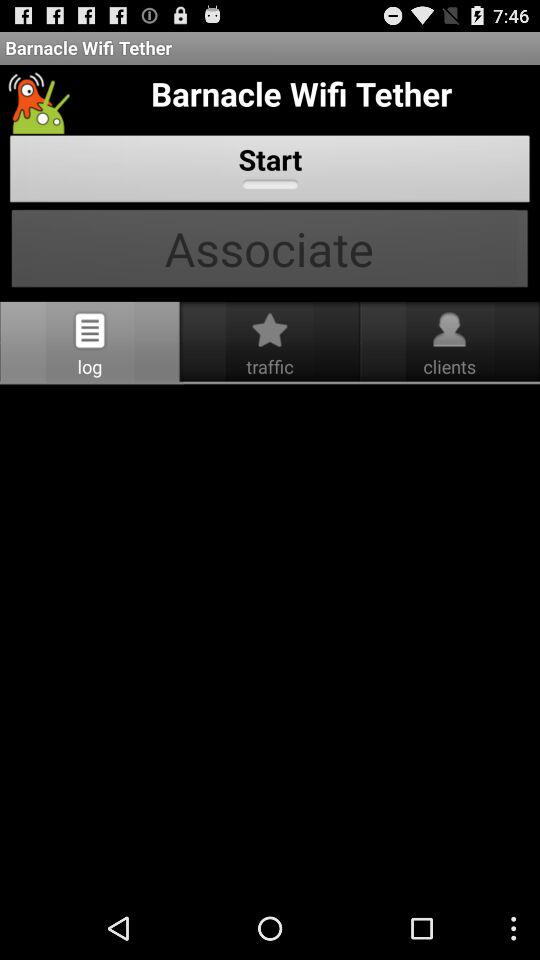What are the names of the clients that are listed?
When the provided information is insufficient, respond with <no answer>. <no answer> 